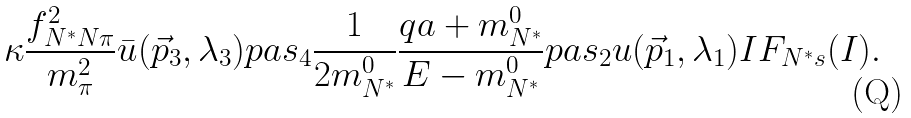<formula> <loc_0><loc_0><loc_500><loc_500>\kappa \frac { f ^ { 2 } _ { N ^ { * } N \pi } } { m _ { \pi } ^ { 2 } } \bar { u } ( \vec { p } _ { 3 } , \lambda _ { 3 } ) p \sl a s _ { 4 } \frac { 1 } { 2 m ^ { 0 } _ { N ^ { * } } } \frac { q \sl a + m ^ { 0 } _ { N ^ { * } } } { E - m ^ { 0 } _ { N ^ { * } } } p \sl a s _ { 2 } u ( \vec { p } _ { 1 } , \lambda _ { 1 } ) I F _ { N ^ { * } s } ( I ) .</formula> 